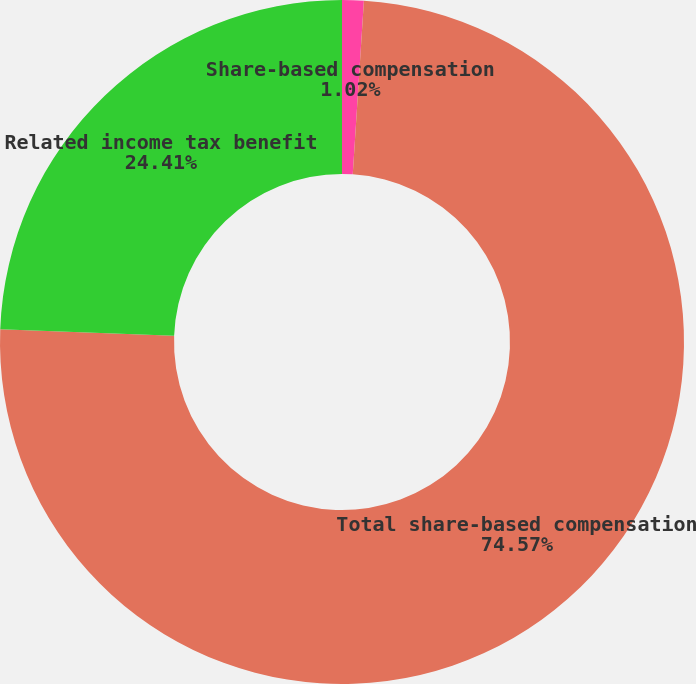Convert chart. <chart><loc_0><loc_0><loc_500><loc_500><pie_chart><fcel>Share-based compensation<fcel>Total share-based compensation<fcel>Related income tax benefit<nl><fcel>1.02%<fcel>74.58%<fcel>24.41%<nl></chart> 